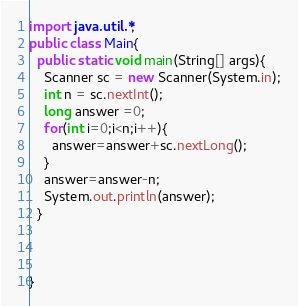<code> <loc_0><loc_0><loc_500><loc_500><_Java_>import java.util.*;
public class Main{
  public static void main(String[] args){
    Scanner sc = new Scanner(System.in);
    int n = sc.nextInt();
    long answer =0;
    for(int i=0;i<n;i++){
      answer=answer+sc.nextLong();
    }
    answer=answer-n;
    System.out.println(answer);
  }
  

  
}
</code> 